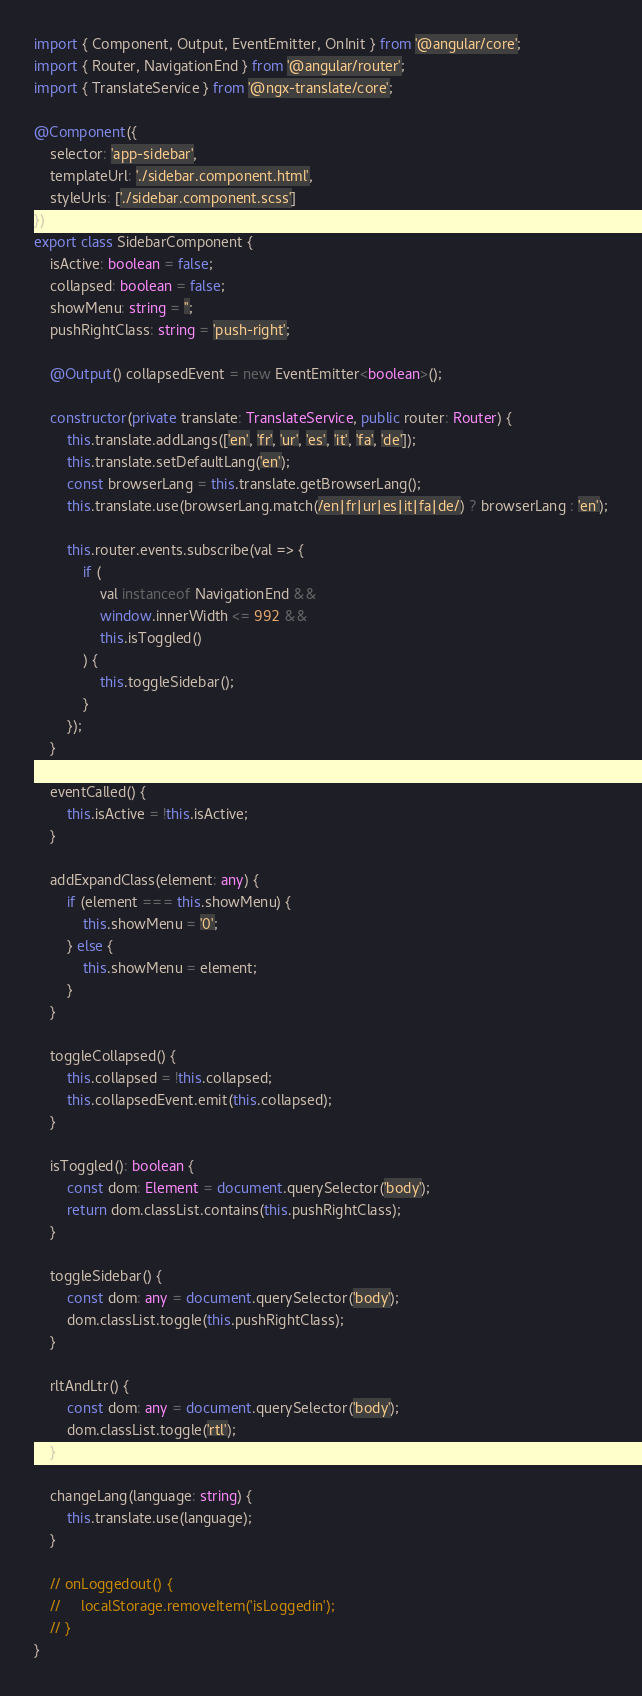<code> <loc_0><loc_0><loc_500><loc_500><_TypeScript_>import { Component, Output, EventEmitter, OnInit } from '@angular/core';
import { Router, NavigationEnd } from '@angular/router';
import { TranslateService } from '@ngx-translate/core';

@Component({
    selector: 'app-sidebar',
    templateUrl: './sidebar.component.html',
    styleUrls: ['./sidebar.component.scss']
})
export class SidebarComponent {
    isActive: boolean = false;
    collapsed: boolean = false;
    showMenu: string = '';
    pushRightClass: string = 'push-right';

    @Output() collapsedEvent = new EventEmitter<boolean>();
    
    constructor(private translate: TranslateService, public router: Router) {
        this.translate.addLangs(['en', 'fr', 'ur', 'es', 'it', 'fa', 'de']);
        this.translate.setDefaultLang('en');
        const browserLang = this.translate.getBrowserLang();
        this.translate.use(browserLang.match(/en|fr|ur|es|it|fa|de/) ? browserLang : 'en');

        this.router.events.subscribe(val => {
            if (
                val instanceof NavigationEnd &&
                window.innerWidth <= 992 &&
                this.isToggled()
            ) {
                this.toggleSidebar();
            }
        });
    }

    eventCalled() {
        this.isActive = !this.isActive;
    }

    addExpandClass(element: any) {
        if (element === this.showMenu) {
            this.showMenu = '0';
        } else {
            this.showMenu = element;
        }
    }

    toggleCollapsed() {
        this.collapsed = !this.collapsed;
        this.collapsedEvent.emit(this.collapsed);
    }

    isToggled(): boolean {
        const dom: Element = document.querySelector('body');
        return dom.classList.contains(this.pushRightClass);
    }

    toggleSidebar() {
        const dom: any = document.querySelector('body');
        dom.classList.toggle(this.pushRightClass);
    }

    rltAndLtr() {
        const dom: any = document.querySelector('body');
        dom.classList.toggle('rtl');
    }

    changeLang(language: string) {
        this.translate.use(language);
    }

    // onLoggedout() {
    //     localStorage.removeItem('isLoggedin');
    // }
}
</code> 